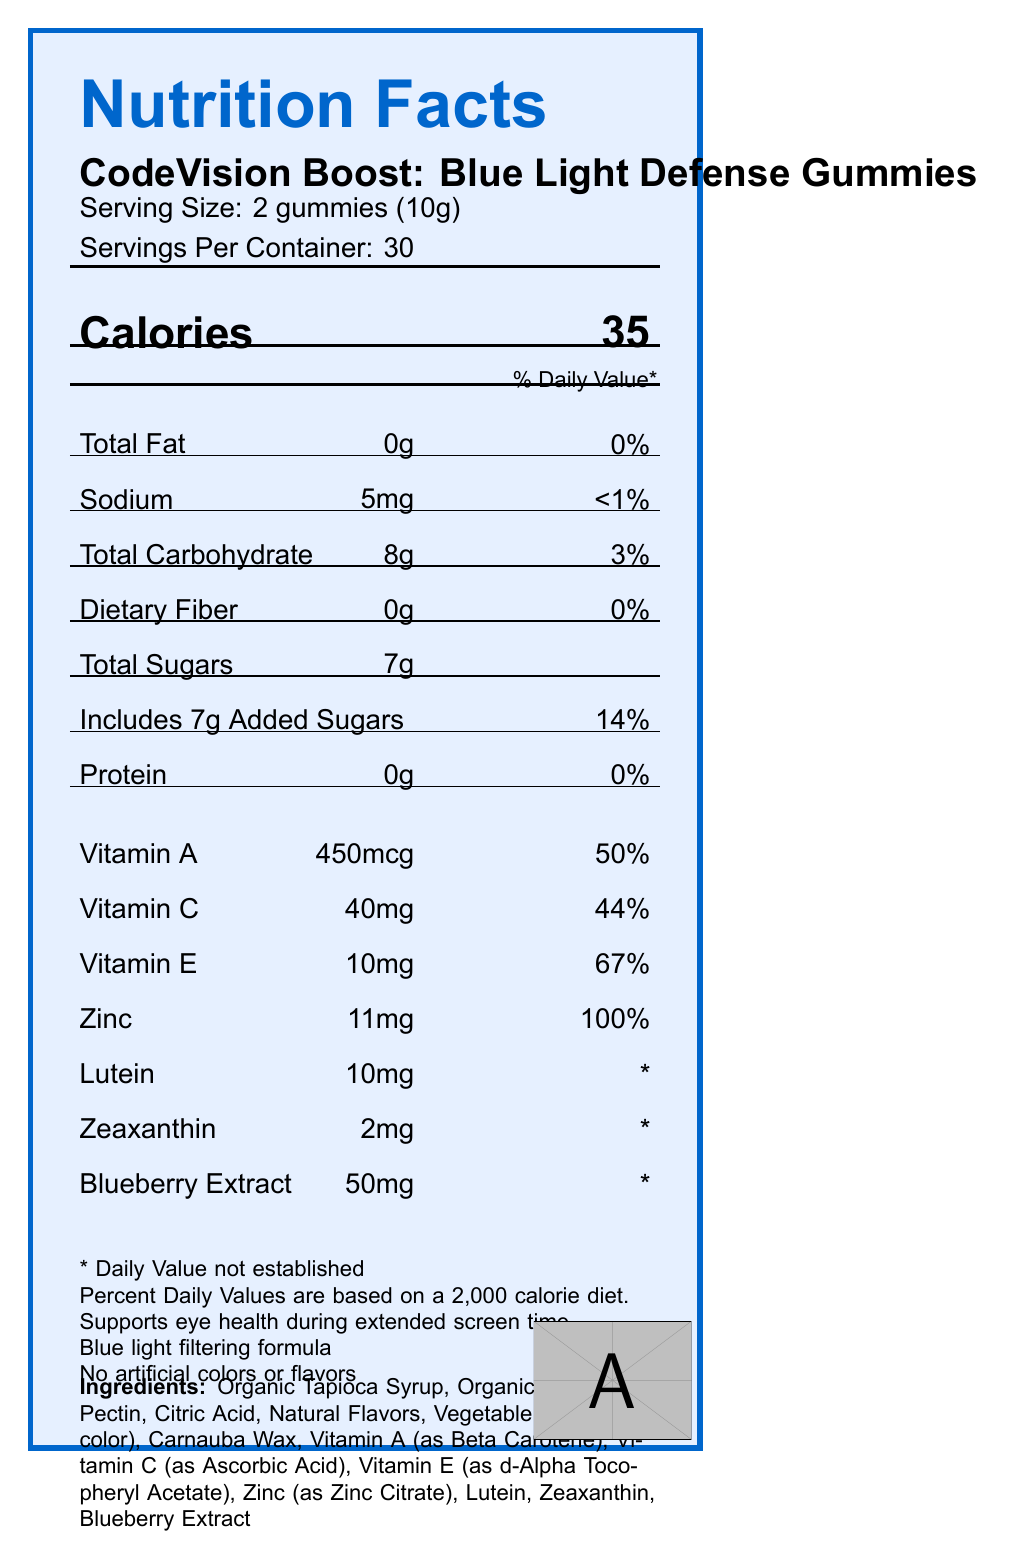what is the serving size for CodeVision Boost Gummies? The serving size is stated in the section "Serving Size: 2 gummies (10g)".
Answer: 2 gummies (10g) how many calories are in one serving of CodeVision Boost Gummies? The calories per serving are mentioned in the "Calories" section.
Answer: 35 calories what is the percentage of daily value for Vitamin E in one serving? The label specifies: "Vitamin E: 10mg, 67%".
Answer: 67% how much Zinc is present in one serving of CodeVision Boost Gummies? The label details the amount of Zinc under vitamins and minerals as "Zinc: 11mg, 100%".
Answer: 11mg can this product help with eye health during extended screen time? The document mentions "Supports eye health during extended screen time" in the footer information.
Answer: Yes which of the following is NOT an ingredient in CodeVision Boost Gummies?
    A. Organic Tapioca Syrup
    B. Gelatin
    C. Blueberry Extract
    D. Pectin The ingredients list does not include Gelatin but does include all other options.
Answer: B. Gelatin which of these nutrients has the highest percentage of daily value per serving?
    i. Vitamin C
    ii. Vitamin E
    iii. Zinc The daily value for Zinc is 100%, which is higher than Vitamin C's 44% and Vitamin E's 67%.
Answer: iii. Zinc is there any fiber in CodeVision Boost Gummies? The label shows "Dietary Fiber 0g" and "0%" daily value.
Answer: No does the product contain any artificial colors or flavors? The footer information clearly states, "No artificial colors or flavors."
Answer: No what is the main purpose of the CodeVision Boost Gummies as advertised? The footer explicitly mentions "Supports eye health during extended screen time" and "Blue light filtering formula."
Answer: To support eye health during extended screen time and filter blue light where is the product manufactured? The manufacturer's address is given in the "manufacturerInfo" section.
Answer: 123 Coder's Lane, Silicon Valley, CA 94000 summarize the nutritional benefits and main features of CodeVision Boost Gummies. The summary captures the key nutritional benefits, special ingredients, and main features like lack of artificial colors/flavors and organic content from the label's data.
Answer: CodeVision Boost Gummies offer a blend of vitamins and minerals, including Vitamin A, Vitamin C, Vitamin E, and Zinc, to support eye health during extended screen time and help filter blue light. They contain no artificial colors or flavors and are made with organic ingredients. Each serving consists of 2 gummies with 35 calories and 8g of carbohydrates, including 7g of added sugars. These gummies include special ingredients like Lutein and Zeaxanthin, essential for eye health. what are the total carbohydrates in one serving? This information is listed under the "Total Carbohydrate" section along with a 3% daily value.
Answer: 8g which vitamins are included in CodeVision Boost Gummies? The vitamins are listed in the nutrition information table, showing their amounts and daily values.
Answer: Vitamin A, Vitamin C, and Vitamin E is there any allergen information on the label? The document mentions, "Manufactured in a facility that processes tree nuts and soy."
Answer: Yes what is the recommended storage condition for the product? The label specifies the storage condition in the "storage" section.
Answer: Store in a cool, dry place away from direct sunlight. how much Lutein is present in the gummies? Under the vitamins and minerals, it shows "Lutein: 10mg".
Answer: 10mg does the document provide information about the price of the CodeVision Boost Gummies? The rendered document does not include any details regarding the price of the product.
Answer: Not enough information 